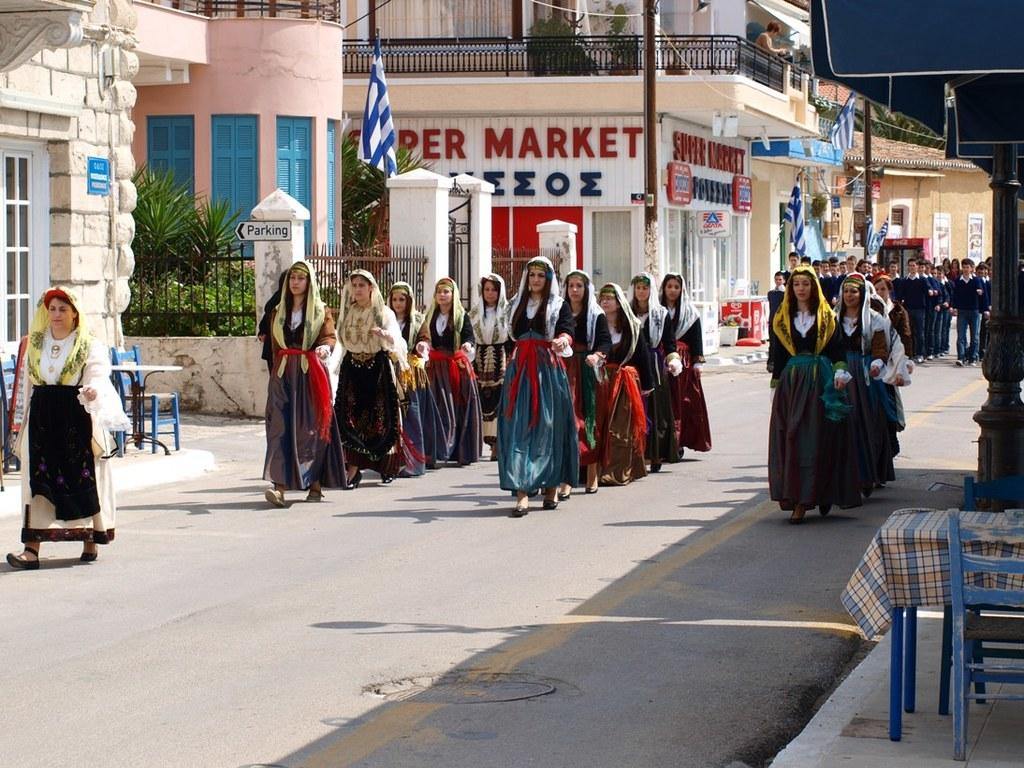What is the main subject of the image? The main subject of the image is a group of persons standing in the middle of the image. What can be seen in the background of the image? There are buildings in the background of the image. What is at the bottom of the image? There is a road at the bottom of the image. What type of quarter is being used by the group of persons in the image? There is no mention of a quarter or any currency in the image, so it cannot be determined from the image. 